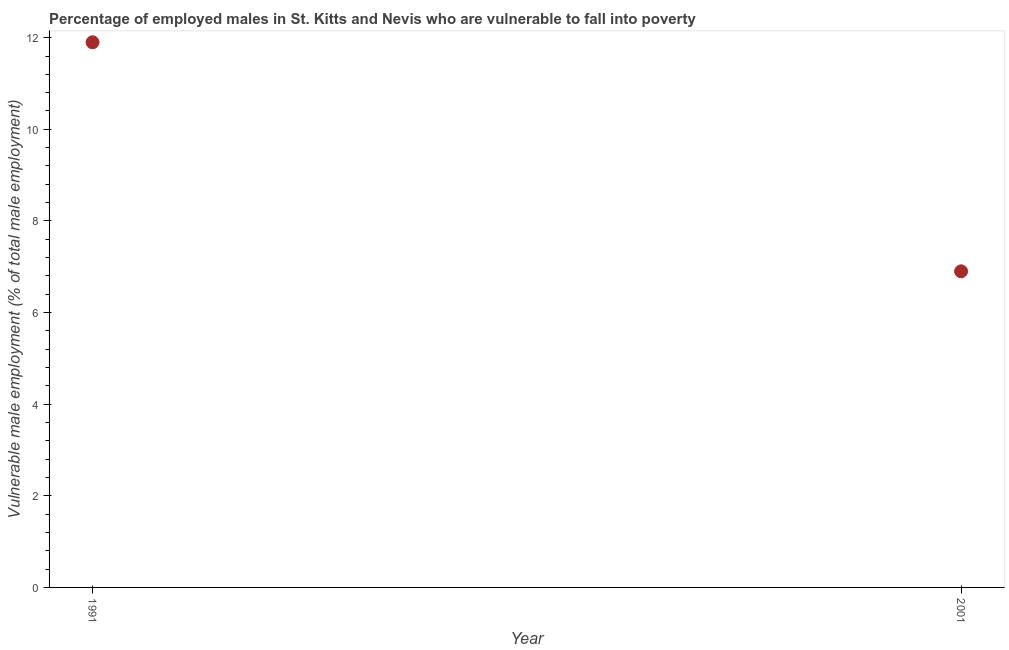What is the percentage of employed males who are vulnerable to fall into poverty in 1991?
Give a very brief answer. 11.9. Across all years, what is the maximum percentage of employed males who are vulnerable to fall into poverty?
Keep it short and to the point. 11.9. Across all years, what is the minimum percentage of employed males who are vulnerable to fall into poverty?
Provide a short and direct response. 6.9. In which year was the percentage of employed males who are vulnerable to fall into poverty maximum?
Offer a terse response. 1991. In which year was the percentage of employed males who are vulnerable to fall into poverty minimum?
Keep it short and to the point. 2001. What is the sum of the percentage of employed males who are vulnerable to fall into poverty?
Your answer should be compact. 18.8. What is the difference between the percentage of employed males who are vulnerable to fall into poverty in 1991 and 2001?
Your response must be concise. 5. What is the average percentage of employed males who are vulnerable to fall into poverty per year?
Your response must be concise. 9.4. What is the median percentage of employed males who are vulnerable to fall into poverty?
Provide a short and direct response. 9.4. In how many years, is the percentage of employed males who are vulnerable to fall into poverty greater than 8.8 %?
Offer a terse response. 1. Do a majority of the years between 2001 and 1991 (inclusive) have percentage of employed males who are vulnerable to fall into poverty greater than 10.4 %?
Your answer should be very brief. No. What is the ratio of the percentage of employed males who are vulnerable to fall into poverty in 1991 to that in 2001?
Offer a terse response. 1.72. Is the percentage of employed males who are vulnerable to fall into poverty in 1991 less than that in 2001?
Ensure brevity in your answer.  No. How many dotlines are there?
Provide a succinct answer. 1. How many years are there in the graph?
Make the answer very short. 2. What is the title of the graph?
Provide a short and direct response. Percentage of employed males in St. Kitts and Nevis who are vulnerable to fall into poverty. What is the label or title of the X-axis?
Your answer should be compact. Year. What is the label or title of the Y-axis?
Make the answer very short. Vulnerable male employment (% of total male employment). What is the Vulnerable male employment (% of total male employment) in 1991?
Offer a very short reply. 11.9. What is the Vulnerable male employment (% of total male employment) in 2001?
Offer a terse response. 6.9. What is the difference between the Vulnerable male employment (% of total male employment) in 1991 and 2001?
Your answer should be compact. 5. What is the ratio of the Vulnerable male employment (% of total male employment) in 1991 to that in 2001?
Offer a very short reply. 1.73. 